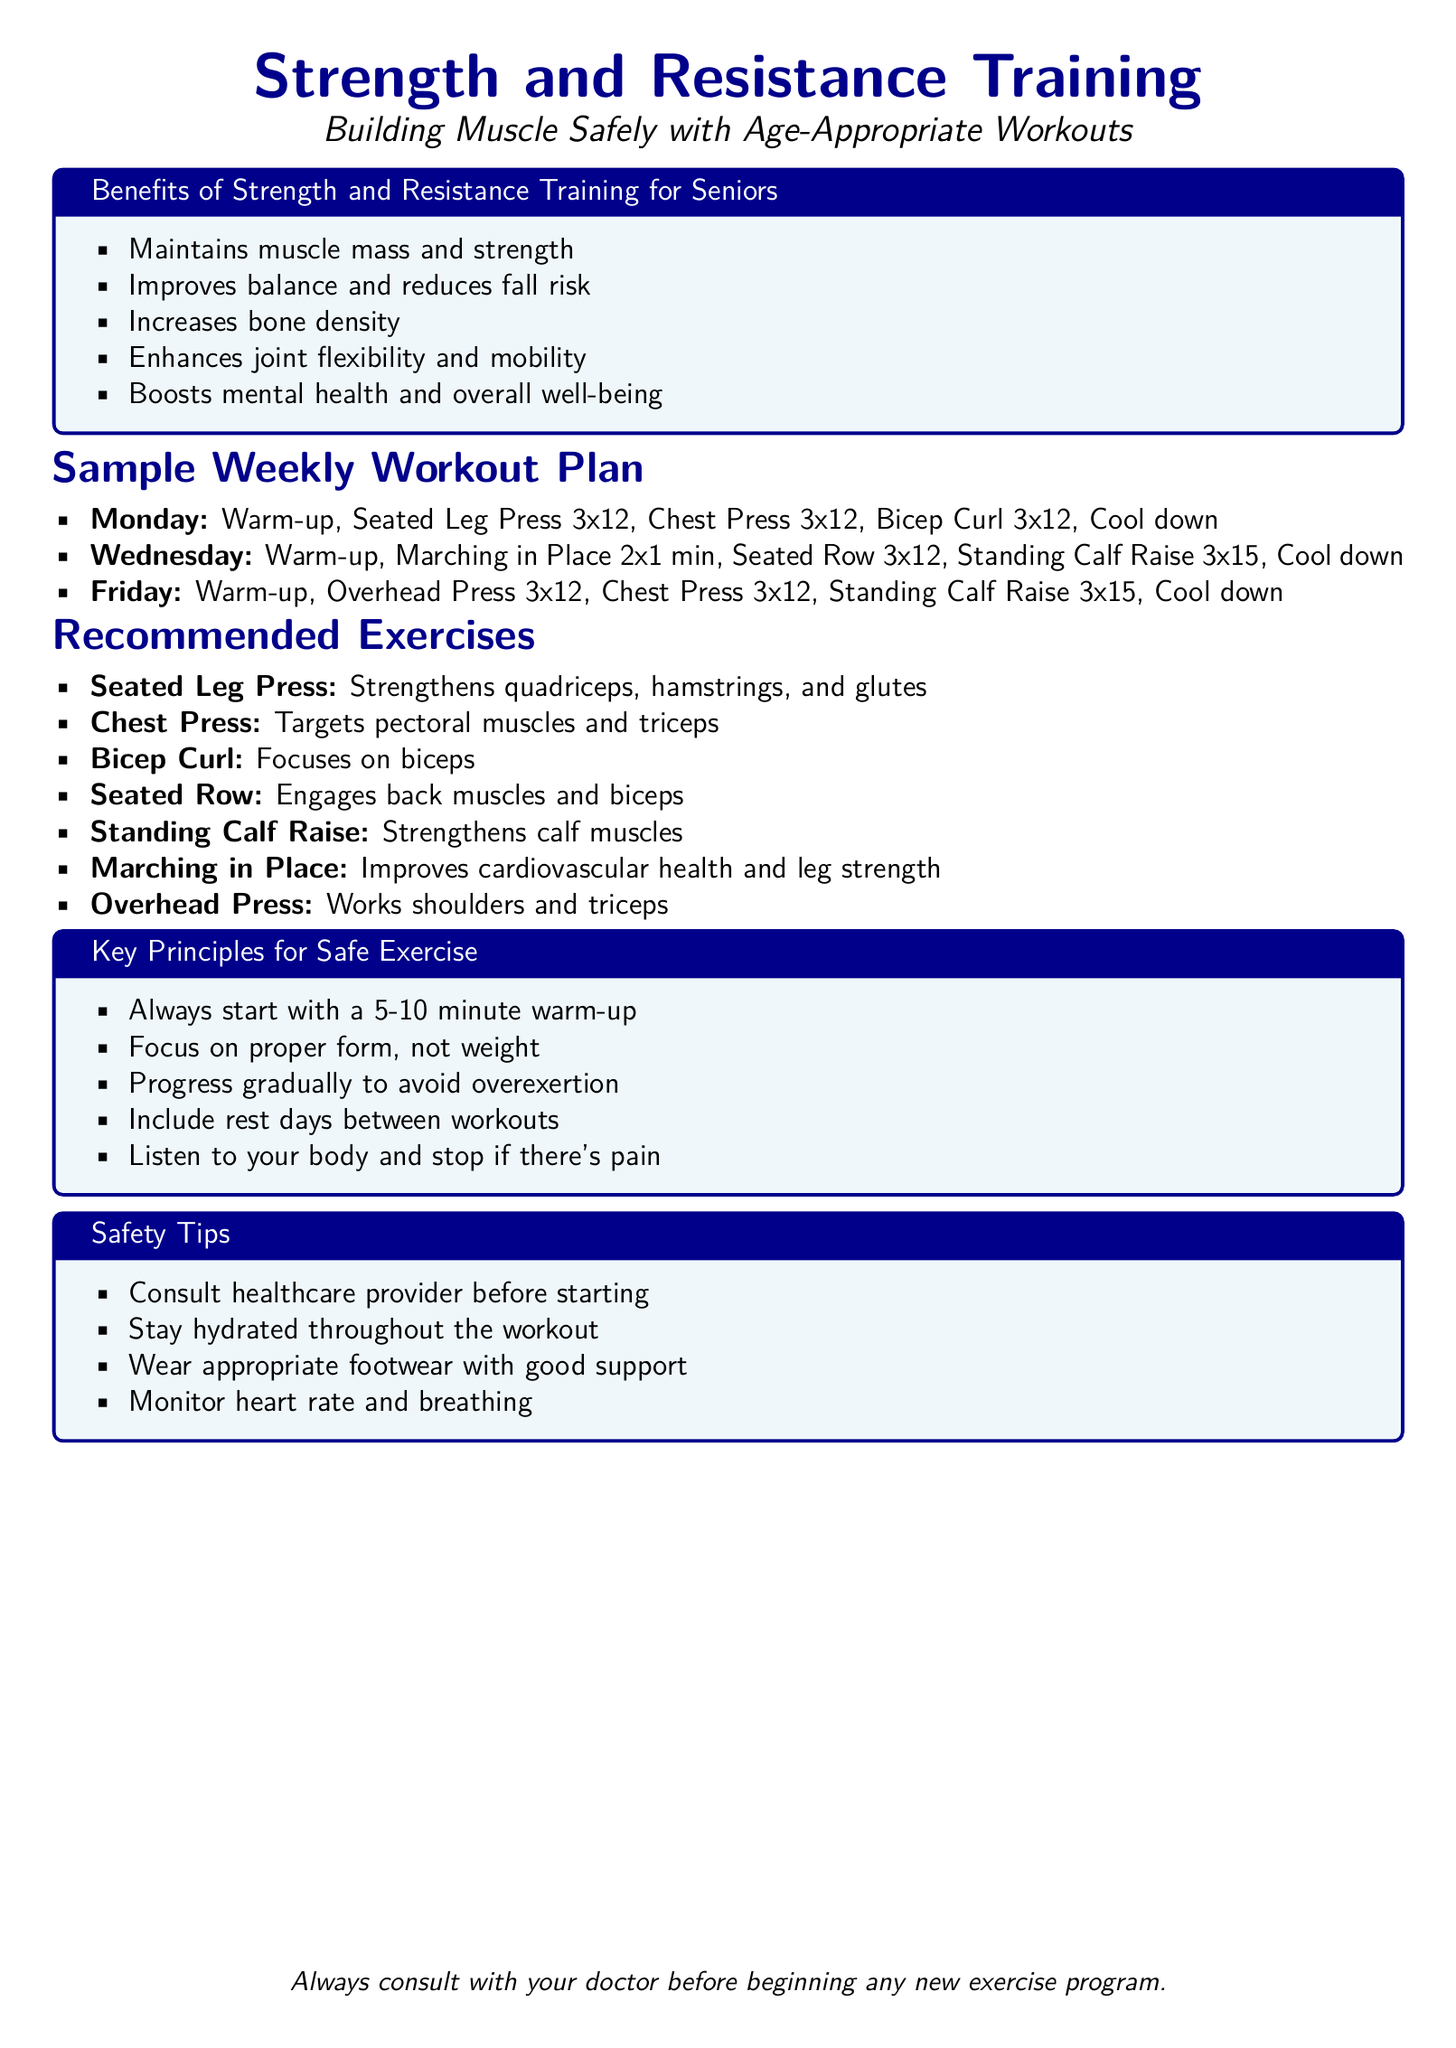What is the title of the workout plan? The title is stated at the top of the document, highlighting the focus on strength and resistance training for seniors.
Answer: Strength and Resistance Training How many exercises are included in the recommended exercises list? There are a total of six distinct exercises listed under the recommended exercises section.
Answer: 7 What day is specified for the seated row exercise? The seated row appears on Wednesday as part of the workout plan mentioned in the weekly schedule.
Answer: Wednesday What is the purpose of the seated leg press exercise? The document states that the seated leg press strengthens specific muscle groups, providing insight into its benefits.
Answer: Strengthens quadriceps, hamstrings, and glutes How many repetitions are recommended for the standing calf raise exercise? The recommended set for this exercise is outlined in the weekly workout plan, specifying the number of repetitions.
Answer: 15 What is one key principle for safe exercise mentioned in the document? The document emphasizes the importance of starting with a warm-up, highlighting safety in exercise practices.
Answer: Always start with a 5-10 minute warm-up What safety tip is suggested regarding footwear? The document includes recommendations on footwear to ensure safety during workouts.
Answer: Wear appropriate footwear with good support What benefit of strength training is related to fall risk? One of the benefits listed directly addresses the issue of balance and its importance in fall risk reduction for seniors.
Answer: Improves balance and reduces fall risk 